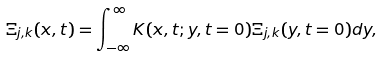<formula> <loc_0><loc_0><loc_500><loc_500>\Xi _ { j , k } ( x , t ) = \int \nolimits _ { - \infty } ^ { \infty } K ( x , t ; y , t = 0 ) \Xi _ { j , k } ( y , t = 0 ) d y ,</formula> 